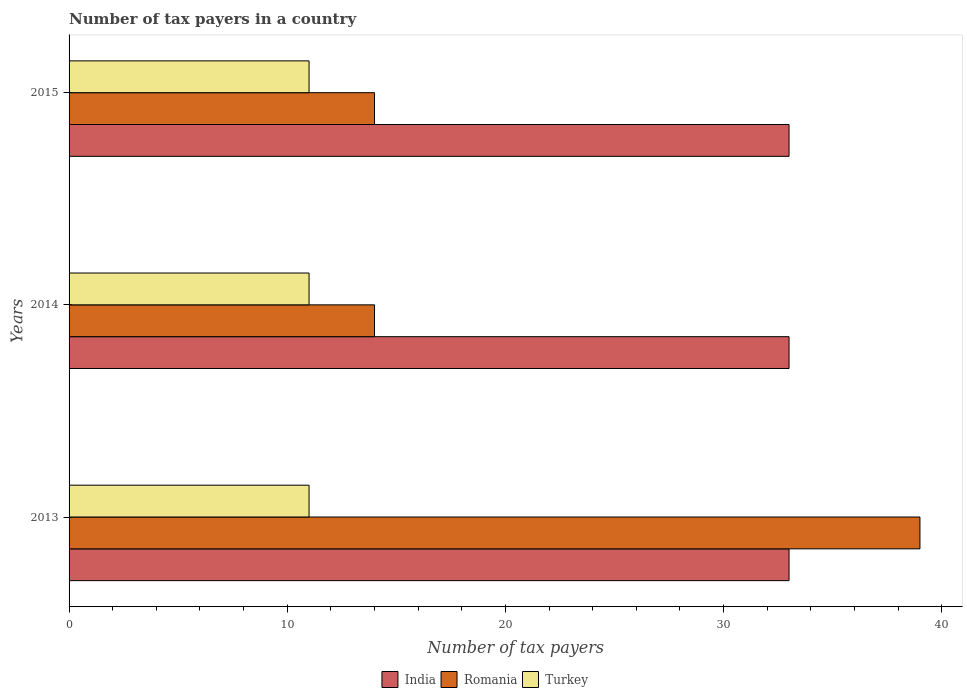How many bars are there on the 3rd tick from the top?
Provide a succinct answer. 3. How many bars are there on the 3rd tick from the bottom?
Offer a very short reply. 3. What is the label of the 1st group of bars from the top?
Ensure brevity in your answer.  2015. What is the number of tax payers in in India in 2013?
Your answer should be compact. 33. Across all years, what is the maximum number of tax payers in in Turkey?
Your response must be concise. 11. Across all years, what is the minimum number of tax payers in in Romania?
Your response must be concise. 14. In which year was the number of tax payers in in India maximum?
Offer a very short reply. 2013. What is the total number of tax payers in in India in the graph?
Offer a very short reply. 99. What is the difference between the number of tax payers in in India in 2014 and that in 2015?
Your answer should be very brief. 0. What is the difference between the number of tax payers in in Turkey in 2014 and the number of tax payers in in Romania in 2015?
Keep it short and to the point. -3. What is the average number of tax payers in in Romania per year?
Offer a terse response. 22.33. Is the number of tax payers in in India in 2013 less than that in 2015?
Your response must be concise. No. Is the difference between the number of tax payers in in India in 2013 and 2014 greater than the difference between the number of tax payers in in Turkey in 2013 and 2014?
Offer a terse response. No. In how many years, is the number of tax payers in in India greater than the average number of tax payers in in India taken over all years?
Offer a terse response. 0. What does the 1st bar from the top in 2015 represents?
Your answer should be very brief. Turkey. What does the 2nd bar from the bottom in 2013 represents?
Provide a succinct answer. Romania. Is it the case that in every year, the sum of the number of tax payers in in India and number of tax payers in in Romania is greater than the number of tax payers in in Turkey?
Provide a short and direct response. Yes. How many bars are there?
Offer a terse response. 9. What is the difference between two consecutive major ticks on the X-axis?
Make the answer very short. 10. Where does the legend appear in the graph?
Your answer should be compact. Bottom center. How are the legend labels stacked?
Give a very brief answer. Horizontal. What is the title of the graph?
Make the answer very short. Number of tax payers in a country. What is the label or title of the X-axis?
Offer a terse response. Number of tax payers. What is the Number of tax payers of India in 2013?
Your answer should be very brief. 33. What is the Number of tax payers in Turkey in 2013?
Keep it short and to the point. 11. What is the Number of tax payers of India in 2014?
Your response must be concise. 33. What is the Number of tax payers in Turkey in 2015?
Provide a succinct answer. 11. Across all years, what is the maximum Number of tax payers of India?
Provide a short and direct response. 33. Across all years, what is the minimum Number of tax payers of Romania?
Your answer should be very brief. 14. Across all years, what is the minimum Number of tax payers of Turkey?
Keep it short and to the point. 11. What is the total Number of tax payers of India in the graph?
Offer a very short reply. 99. What is the difference between the Number of tax payers in Romania in 2013 and that in 2014?
Ensure brevity in your answer.  25. What is the difference between the Number of tax payers of India in 2014 and that in 2015?
Provide a short and direct response. 0. What is the difference between the Number of tax payers in Turkey in 2014 and that in 2015?
Your answer should be very brief. 0. What is the difference between the Number of tax payers of India in 2013 and the Number of tax payers of Romania in 2014?
Give a very brief answer. 19. What is the difference between the Number of tax payers in India in 2013 and the Number of tax payers in Romania in 2015?
Offer a terse response. 19. What is the difference between the Number of tax payers in India in 2013 and the Number of tax payers in Turkey in 2015?
Give a very brief answer. 22. What is the difference between the Number of tax payers of India in 2014 and the Number of tax payers of Romania in 2015?
Keep it short and to the point. 19. What is the difference between the Number of tax payers of India in 2014 and the Number of tax payers of Turkey in 2015?
Your answer should be very brief. 22. What is the average Number of tax payers in Romania per year?
Provide a succinct answer. 22.33. What is the average Number of tax payers in Turkey per year?
Your answer should be compact. 11. In the year 2013, what is the difference between the Number of tax payers of India and Number of tax payers of Romania?
Ensure brevity in your answer.  -6. In the year 2013, what is the difference between the Number of tax payers of India and Number of tax payers of Turkey?
Your response must be concise. 22. In the year 2014, what is the difference between the Number of tax payers of India and Number of tax payers of Romania?
Your response must be concise. 19. What is the ratio of the Number of tax payers in Romania in 2013 to that in 2014?
Your answer should be compact. 2.79. What is the ratio of the Number of tax payers in Turkey in 2013 to that in 2014?
Make the answer very short. 1. What is the ratio of the Number of tax payers of Romania in 2013 to that in 2015?
Your answer should be compact. 2.79. What is the ratio of the Number of tax payers in Turkey in 2013 to that in 2015?
Provide a succinct answer. 1. What is the difference between the highest and the second highest Number of tax payers of Turkey?
Provide a succinct answer. 0. What is the difference between the highest and the lowest Number of tax payers in India?
Give a very brief answer. 0. What is the difference between the highest and the lowest Number of tax payers in Romania?
Offer a very short reply. 25. What is the difference between the highest and the lowest Number of tax payers of Turkey?
Give a very brief answer. 0. 